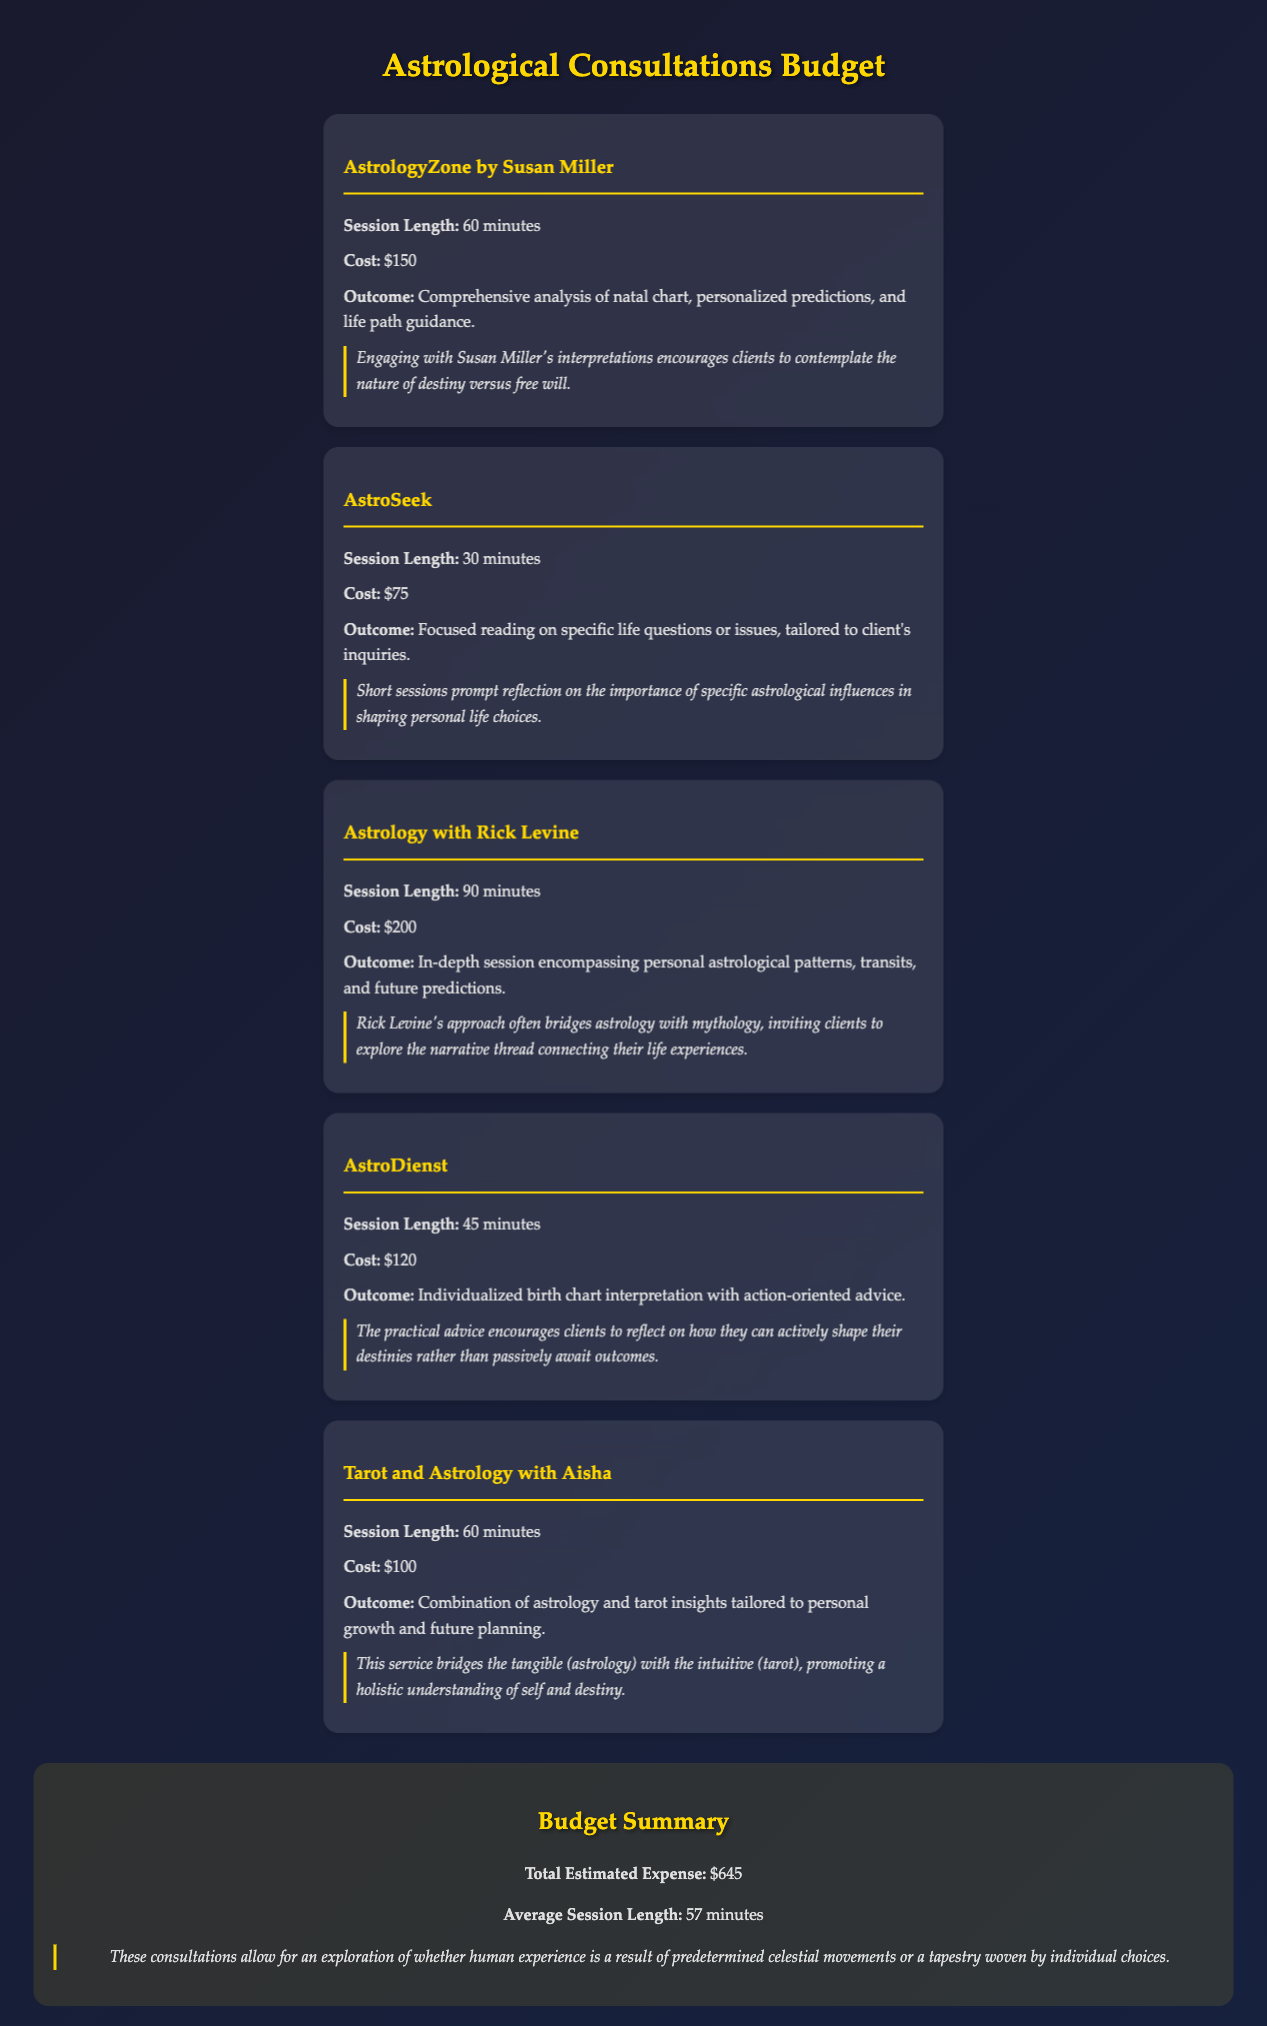What is the name of the first service provider? The first service provider is listed as "AstrologyZone by Susan Miller" in the document.
Answer: AstrologyZone by Susan Miller How long is the session with Rick Levine? The document states that the session length with Rick Levine is 90 minutes.
Answer: 90 minutes What is the cost of a consultation with AstroSeek? The document provides the cost for a consultation with AstroSeek as $75.
Answer: $75 How many total consultations are listed in the budget? The document lists a total of five consultations.
Answer: 5 What is the total estimated expense for all consultations? The total estimated expense for all consultations is explicitly provided in the summary section of the document as $645.
Answer: $645 Which consultation emphasizes the practical advice for shaping one's destiny? The document indicates that "AstroDienst" emphasizes practical advice for actively shaping destinies.
Answer: AstroDienst What is the average session length across all consultations? The document summarizes the average session length as 57 minutes.
Answer: 57 minutes Which consultation combines astrology and tarot insights? The document specifies that the consultation "Tarot and Astrology with Aisha" combines astrology and tarot insights.
Answer: Tarot and Astrology with Aisha What theme do Rick Levine's sessions promote according to the document? According to the document, Rick Levine's sessions promote exploring the narrative thread connecting life experiences.
Answer: Narrative thread connecting life experiences 